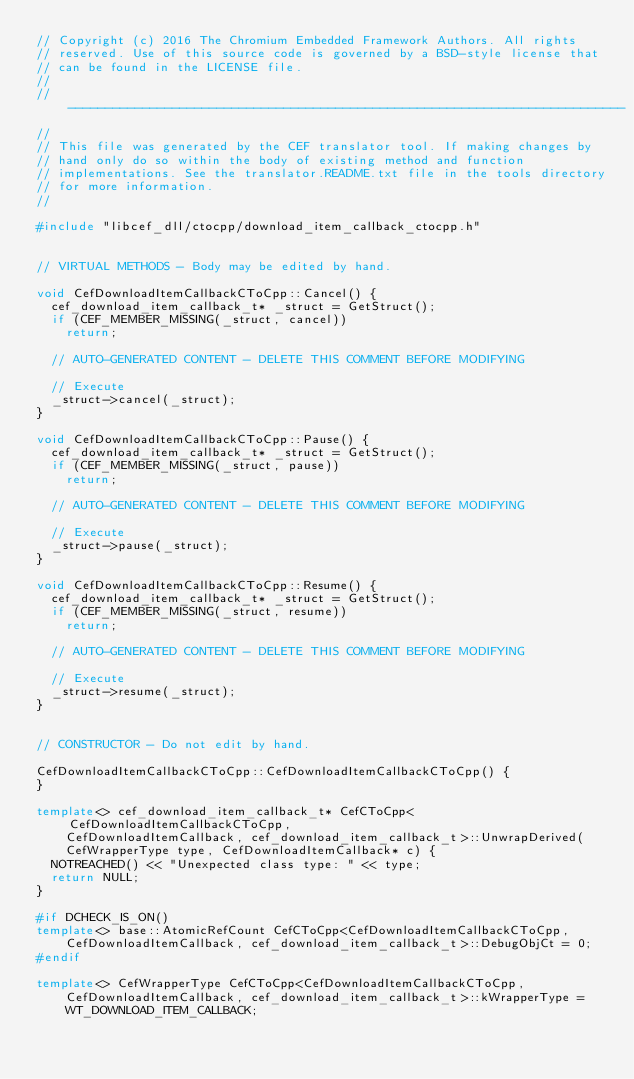<code> <loc_0><loc_0><loc_500><loc_500><_C++_>// Copyright (c) 2016 The Chromium Embedded Framework Authors. All rights
// reserved. Use of this source code is governed by a BSD-style license that
// can be found in the LICENSE file.
//
// ---------------------------------------------------------------------------
//
// This file was generated by the CEF translator tool. If making changes by
// hand only do so within the body of existing method and function
// implementations. See the translator.README.txt file in the tools directory
// for more information.
//

#include "libcef_dll/ctocpp/download_item_callback_ctocpp.h"


// VIRTUAL METHODS - Body may be edited by hand.

void CefDownloadItemCallbackCToCpp::Cancel() {
  cef_download_item_callback_t* _struct = GetStruct();
  if (CEF_MEMBER_MISSING(_struct, cancel))
    return;

  // AUTO-GENERATED CONTENT - DELETE THIS COMMENT BEFORE MODIFYING

  // Execute
  _struct->cancel(_struct);
}

void CefDownloadItemCallbackCToCpp::Pause() {
  cef_download_item_callback_t* _struct = GetStruct();
  if (CEF_MEMBER_MISSING(_struct, pause))
    return;

  // AUTO-GENERATED CONTENT - DELETE THIS COMMENT BEFORE MODIFYING

  // Execute
  _struct->pause(_struct);
}

void CefDownloadItemCallbackCToCpp::Resume() {
  cef_download_item_callback_t* _struct = GetStruct();
  if (CEF_MEMBER_MISSING(_struct, resume))
    return;

  // AUTO-GENERATED CONTENT - DELETE THIS COMMENT BEFORE MODIFYING

  // Execute
  _struct->resume(_struct);
}


// CONSTRUCTOR - Do not edit by hand.

CefDownloadItemCallbackCToCpp::CefDownloadItemCallbackCToCpp() {
}

template<> cef_download_item_callback_t* CefCToCpp<CefDownloadItemCallbackCToCpp,
    CefDownloadItemCallback, cef_download_item_callback_t>::UnwrapDerived(
    CefWrapperType type, CefDownloadItemCallback* c) {
  NOTREACHED() << "Unexpected class type: " << type;
  return NULL;
}

#if DCHECK_IS_ON()
template<> base::AtomicRefCount CefCToCpp<CefDownloadItemCallbackCToCpp,
    CefDownloadItemCallback, cef_download_item_callback_t>::DebugObjCt = 0;
#endif

template<> CefWrapperType CefCToCpp<CefDownloadItemCallbackCToCpp,
    CefDownloadItemCallback, cef_download_item_callback_t>::kWrapperType =
    WT_DOWNLOAD_ITEM_CALLBACK;
</code> 